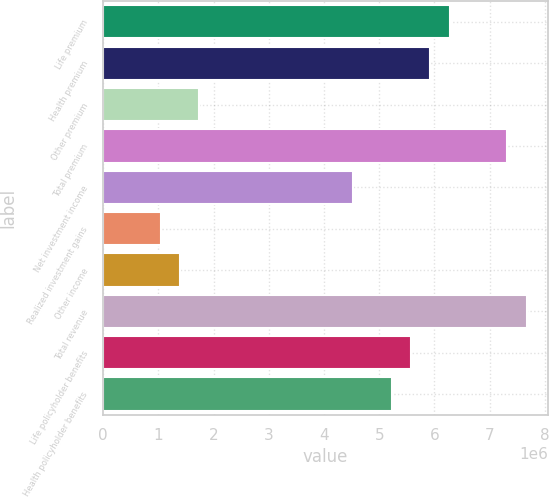Convert chart. <chart><loc_0><loc_0><loc_500><loc_500><bar_chart><fcel>Life premium<fcel>Health premium<fcel>Other premium<fcel>Total premium<fcel>Net investment income<fcel>Realized investment gains<fcel>Other income<fcel>Total revenue<fcel>Life policyholder benefits<fcel>Health policyholder benefits<nl><fcel>6.27605e+06<fcel>5.92738e+06<fcel>1.74335e+06<fcel>7.32206e+06<fcel>4.53271e+06<fcel>1.04601e+06<fcel>1.39468e+06<fcel>7.67073e+06<fcel>5.57871e+06<fcel>5.23005e+06<nl></chart> 